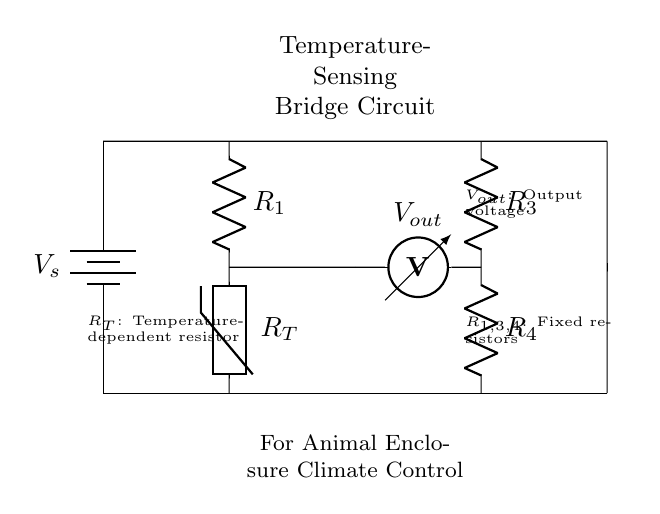What are the fixed resistors in the circuit? The circuit has three fixed resistors labeled as R1, R3, and R4, which provide a stable resistance for the bridge operation.
Answer: R1, R3, R4 What is the role of the thermistor in this circuit? The thermistor, labeled R_T, is a temperature-dependent resistor that changes its resistance based on the temperature, allowing the circuit to sense temperature variations in animal enclosures.
Answer: Temperature sensing What is the output voltage measured across? The output voltage, labeled V_out, is measured across the points between the thermistor (R_T) and fixed resistors (R3 and R4), indicating the balance of the bridge circuit.
Answer: Between R_T and R3/R4 What type of circuit configuration is this? The configuration forms a bridge circuit, allowing for temperature measurements by comparing the resistance of the thermistor with fixed resistors.
Answer: Bridge circuit What happens to V_out when the temperature increases? When temperature increases, the resistance of the thermistor (R_T) decreases, increasing V_out, as the bridge becomes unbalanced.
Answer: V_out increases How are R1 and R3 connected in the circuit? R1 and R3 are connected in parallel to R_T, each forming one arm of the bridge, which helps in balancing the circuit for accurate temperature measurement.
Answer: In parallel What is the main purpose of this temperature-sensing bridge circuit? The main purpose is to maintain optimal conditions in animal enclosures by sensing and responding to temperature changes.
Answer: Climate control 